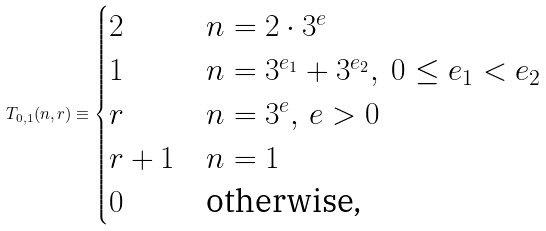<formula> <loc_0><loc_0><loc_500><loc_500>T _ { 0 , 1 } ( n , r ) \equiv \begin{cases} 2 & n = 2 \cdot 3 ^ { e } \\ 1 & n = 3 ^ { e _ { 1 } } + 3 ^ { e _ { 2 } } , \ 0 \leq e _ { 1 } < e _ { 2 } \\ r & n = 3 ^ { e } , \, e > 0 \\ r + 1 & n = 1 \\ 0 & \text {otherwise,} \end{cases}</formula> 